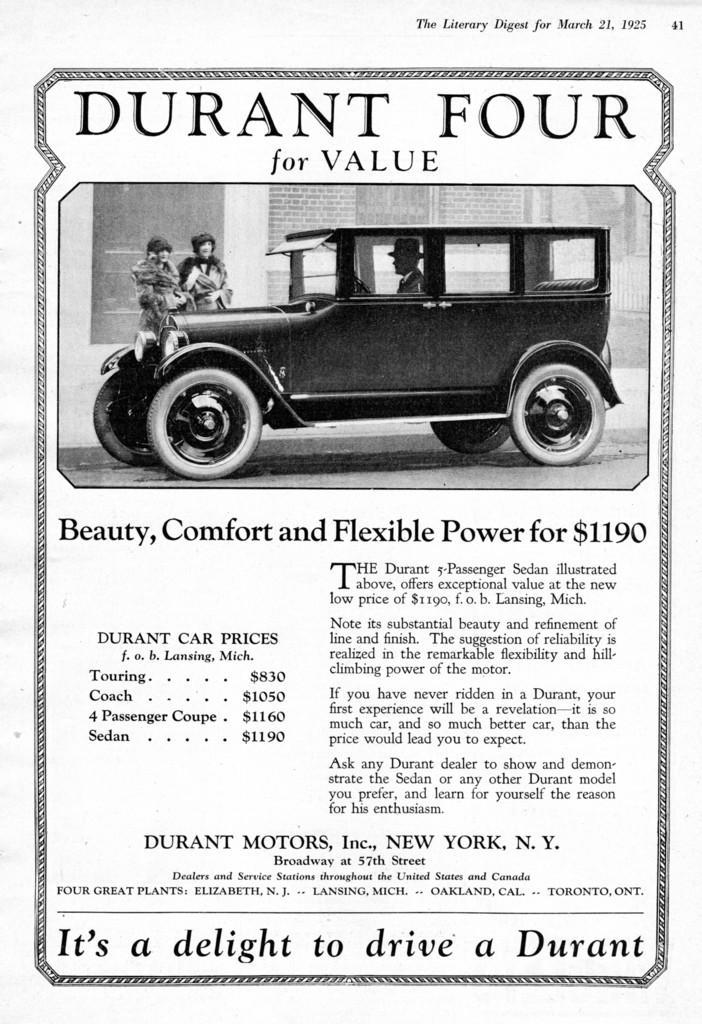How would you summarize this image in a sentence or two? In this picture, we can see some images and some text on it. 